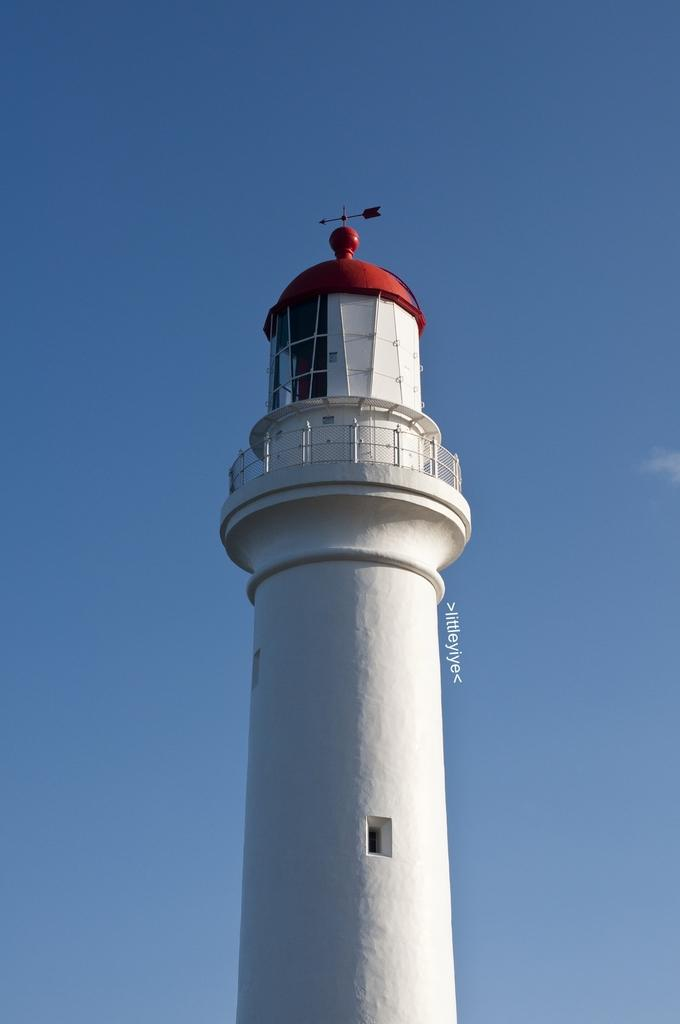What is the main structure in the image? There is a lighthouse in the image. What feature can be seen near the lighthouse? There is a railing in the image. What navigational tool is present in the image? There is a compass in the image. What is visible in the background of the image? The sky is visible in the image. What type of lead is being followed by the geese in the image? There are no geese present in the image, so it is not possible to determine if they are following any lead. What kind of band is playing music in the image? There is no band present in the image, so it is not possible to determine if any music is being played. 